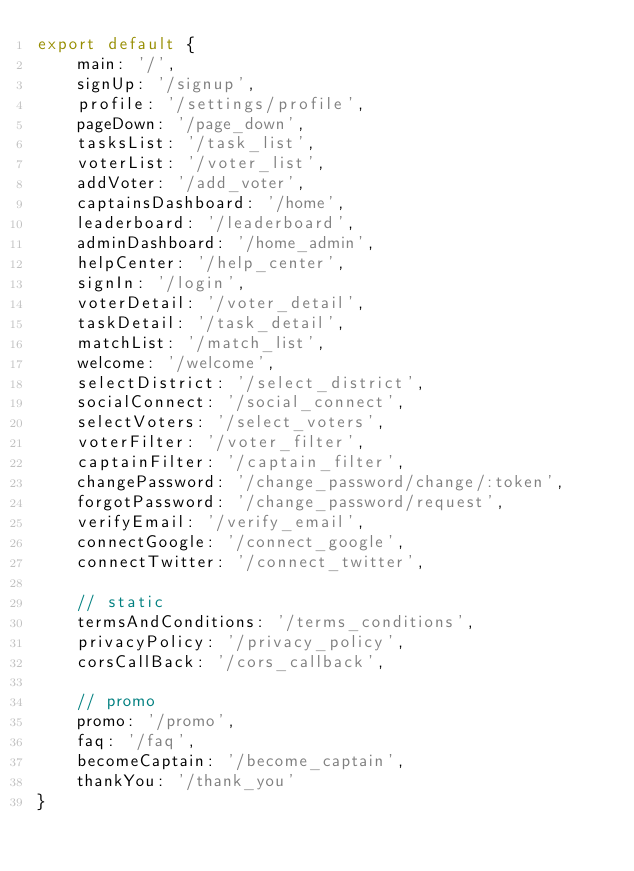<code> <loc_0><loc_0><loc_500><loc_500><_JavaScript_>export default {
    main: '/',
    signUp: '/signup',
    profile: '/settings/profile',
    pageDown: '/page_down',
    tasksList: '/task_list',
    voterList: '/voter_list',
    addVoter: '/add_voter',
    captainsDashboard: '/home',
    leaderboard: '/leaderboard',
    adminDashboard: '/home_admin',
    helpCenter: '/help_center',
    signIn: '/login',
    voterDetail: '/voter_detail',
    taskDetail: '/task_detail',
    matchList: '/match_list',
    welcome: '/welcome',
    selectDistrict: '/select_district',
    socialConnect: '/social_connect',
    selectVoters: '/select_voters',
    voterFilter: '/voter_filter',
    captainFilter: '/captain_filter',
    changePassword: '/change_password/change/:token',
    forgotPassword: '/change_password/request',
    verifyEmail: '/verify_email',
    connectGoogle: '/connect_google',
    connectTwitter: '/connect_twitter',

    // static
    termsAndConditions: '/terms_conditions',
    privacyPolicy: '/privacy_policy',
    corsCallBack: '/cors_callback',

    // promo
    promo: '/promo',
    faq: '/faq',
    becomeCaptain: '/become_captain',
    thankYou: '/thank_you'
}
</code> 